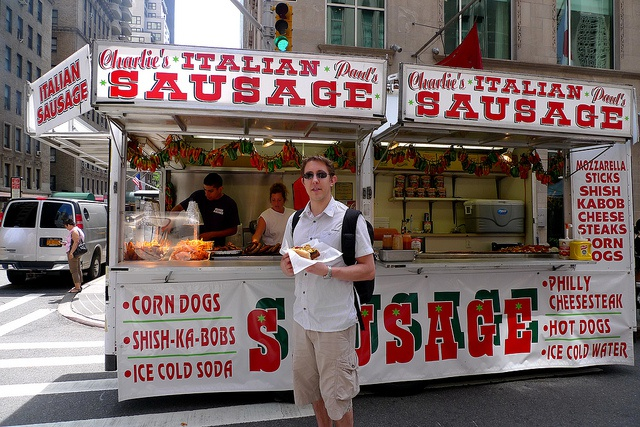Describe the objects in this image and their specific colors. I can see people in black, darkgray, and gray tones, truck in black, darkgray, gray, and lightgray tones, people in black, maroon, and gray tones, backpack in black, darkgray, gray, and maroon tones, and people in black, maroon, and gray tones in this image. 